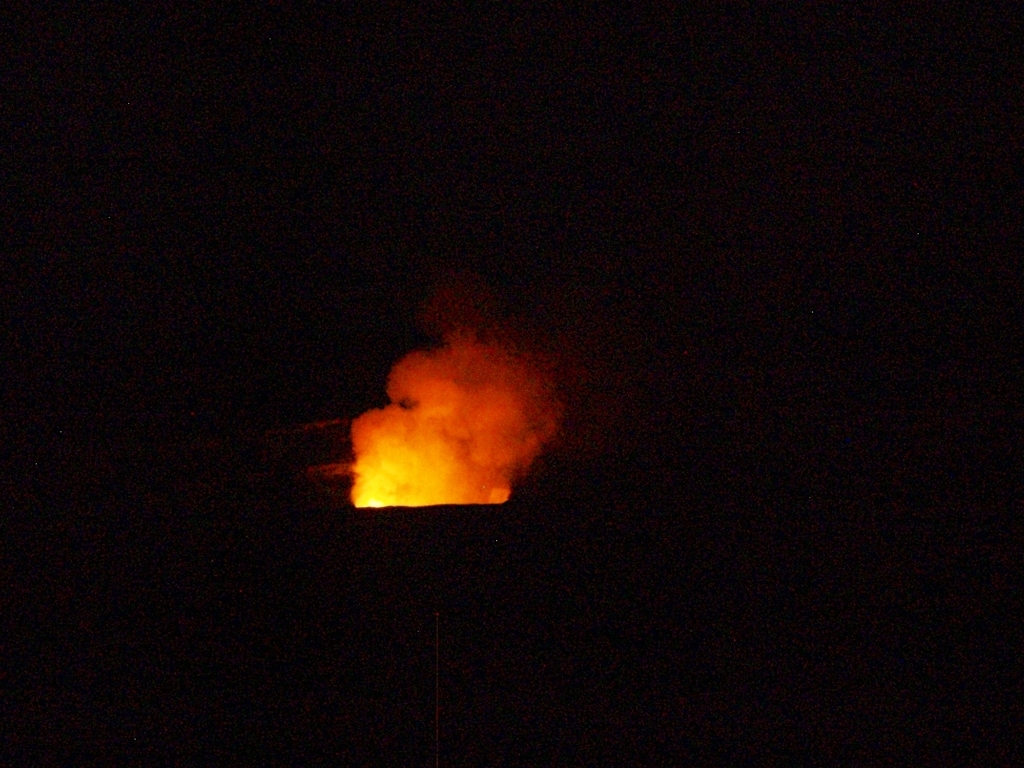Does the poor lighting affect the image quality? Yes, the poor lighting does impact the image quality, leading to reduced visibility and detail. In this instance, the dim light creates a challenging environment for capturing clear images, particularly with the subject appearing overly dark and lacking in definition. Enhancing the brightness or exposure, either while taking the photograph or in post-processing, could improve the clarity and reveal more details of the scene. 